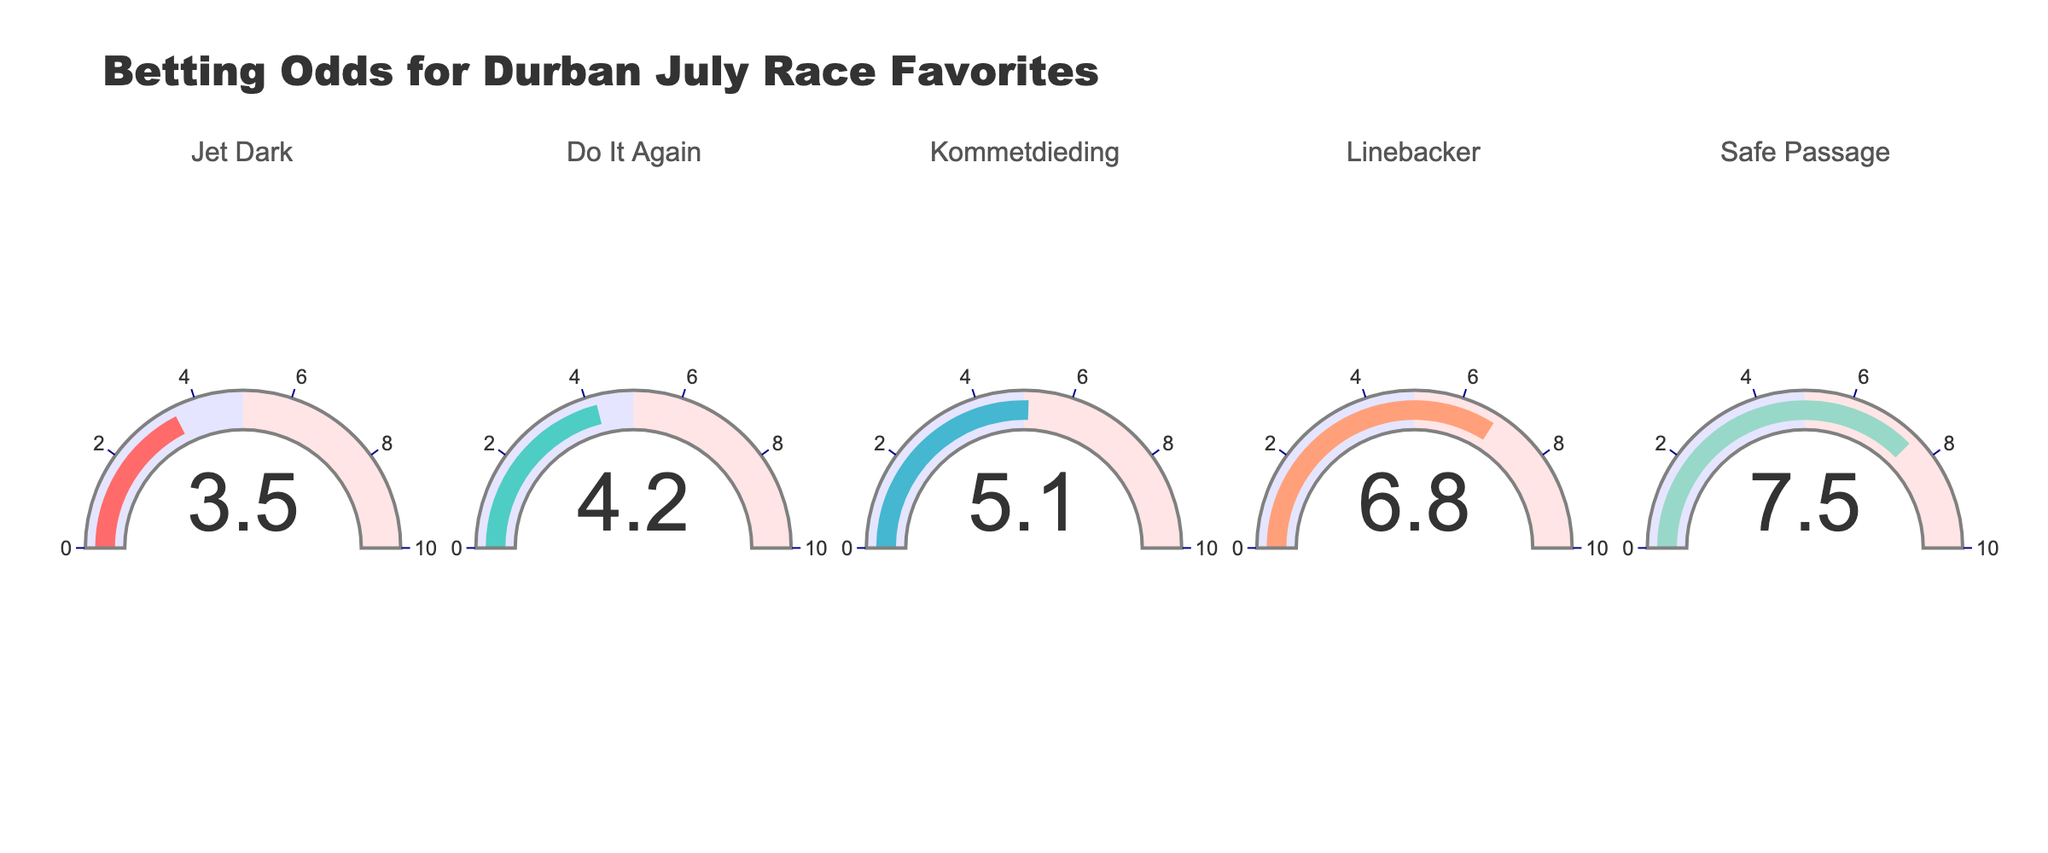What's the title of the figure? The title is written at the top of the figure and reads "Betting Odds for Durban July Race Favorites".
Answer: Betting Odds for Durban July Race Favorites How many horses are displayed in the figure? Each gauge chart shows the betting odds for one horse, and there are five gauge charts in total.
Answer: 5 Which horse has the lowest odds? The lowest odds are indicated by the gauge with the smallest number, which is 3.5 for the horse Jet Dark.
Answer: Jet Dark What are the odds for Kommetdieding? Look at the gauge chart labeled Kommetdieding, which displays a value of 5.1.
Answer: 5.1 Which horse has the highest odds? The gauge with the highest number indicates the highest odds, which is 7.5 for the horse Safe Passage.
Answer: Safe Passage What is the average betting odds for all horses? To find the average, sum the odds for all horses (3.5 + 4.2 + 5.1 + 6.8 + 7.5) and divide by the number of horses (5). So, the average is (27.1 / 5) = 5.42.
Answer: 5.42 How much higher are the odds for Linebacker compared to Do It Again? Subtract the odds for Do It Again (4.2) from the odds for Linebacker (6.8). So, the difference is (6.8 - 4.2) = 2.6.
Answer: 2.6 Which horse has odds closer to 5? Compare the odds values to see which one is closest to 5. Kommetdieding has odds of 5.1, which is closest.
Answer: Kommetdieding Are there more horses with odds above or below 5? Count the horses with odds above 5 (Kommetdieding, Linebacker, Safe Passage) and those below 5 (Jet Dark, Do It Again). There are 3 horses with odds above 5 and 2 below 5.
Answer: Above Which horse has the second lowest odds? Identify the second smallest value after the smallest (which is Jet Dark with 3.5), which is 4.2 for Do It Again.
Answer: Do It Again 